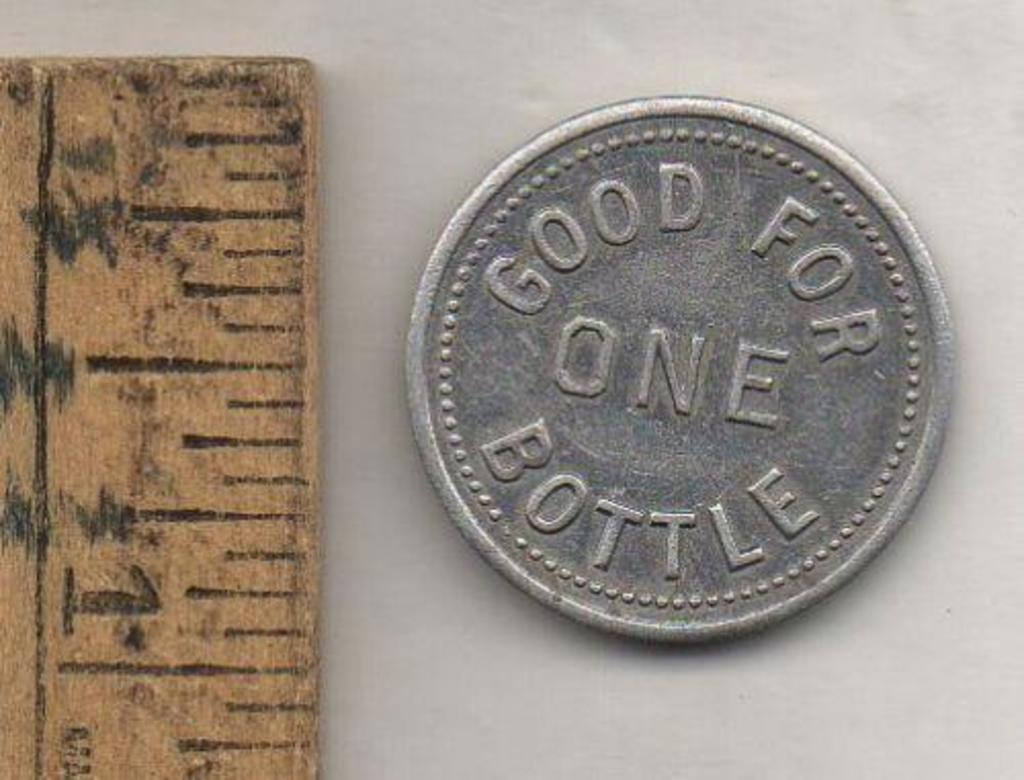<image>
Create a compact narrative representing the image presented. a ruler next to a coin that says good for one bottle 